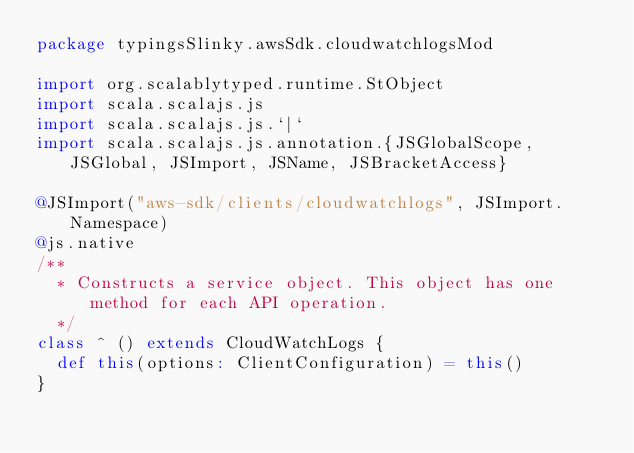Convert code to text. <code><loc_0><loc_0><loc_500><loc_500><_Scala_>package typingsSlinky.awsSdk.cloudwatchlogsMod

import org.scalablytyped.runtime.StObject
import scala.scalajs.js
import scala.scalajs.js.`|`
import scala.scalajs.js.annotation.{JSGlobalScope, JSGlobal, JSImport, JSName, JSBracketAccess}

@JSImport("aws-sdk/clients/cloudwatchlogs", JSImport.Namespace)
@js.native
/**
  * Constructs a service object. This object has one method for each API operation.
  */
class ^ () extends CloudWatchLogs {
  def this(options: ClientConfiguration) = this()
}
</code> 